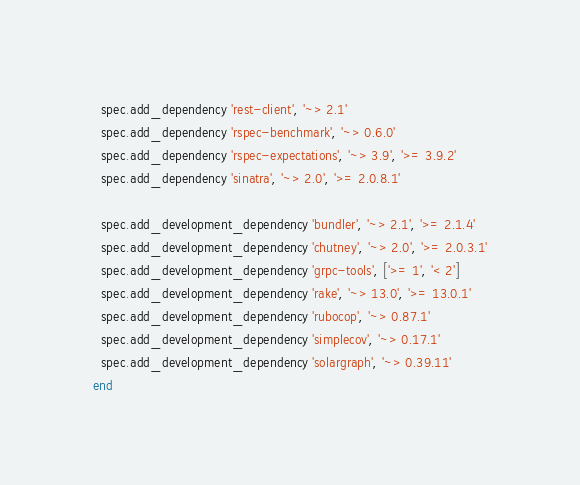<code> <loc_0><loc_0><loc_500><loc_500><_Ruby_>  spec.add_dependency 'rest-client', '~> 2.1'
  spec.add_dependency 'rspec-benchmark', '~> 0.6.0'
  spec.add_dependency 'rspec-expectations', '~> 3.9', '>= 3.9.2'
  spec.add_dependency 'sinatra', '~> 2.0', '>= 2.0.8.1'

  spec.add_development_dependency 'bundler', '~> 2.1', '>= 2.1.4'
  spec.add_development_dependency 'chutney', '~> 2.0', '>= 2.0.3.1'
  spec.add_development_dependency 'grpc-tools', ['>= 1', '< 2']
  spec.add_development_dependency 'rake', '~> 13.0', '>= 13.0.1'
  spec.add_development_dependency 'rubocop', '~> 0.87.1'
  spec.add_development_dependency 'simplecov', '~> 0.17.1'
  spec.add_development_dependency 'solargraph', '~> 0.39.11'
end
</code> 